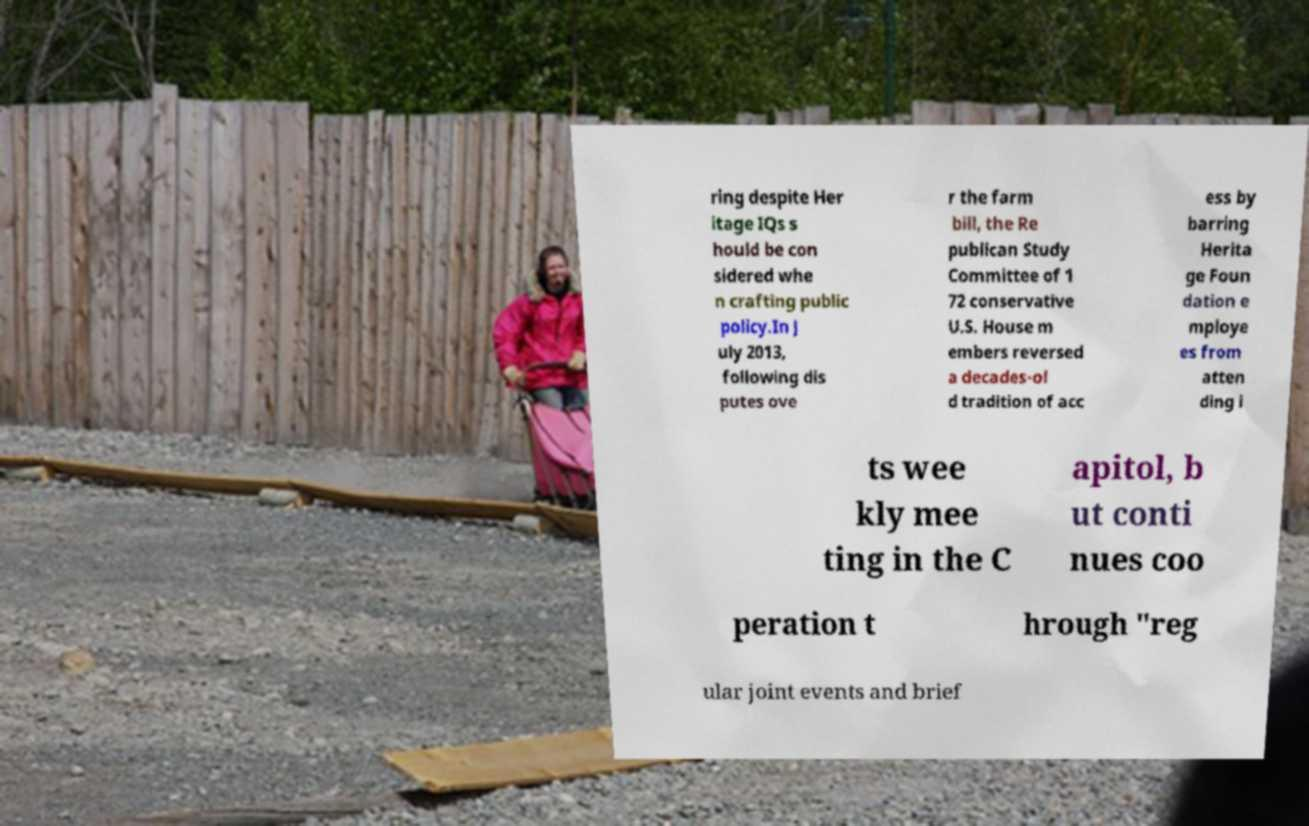Please read and relay the text visible in this image. What does it say? ring despite Her itage IQs s hould be con sidered whe n crafting public policy.In J uly 2013, following dis putes ove r the farm bill, the Re publican Study Committee of 1 72 conservative U.S. House m embers reversed a decades-ol d tradition of acc ess by barring Herita ge Foun dation e mploye es from atten ding i ts wee kly mee ting in the C apitol, b ut conti nues coo peration t hrough "reg ular joint events and brief 